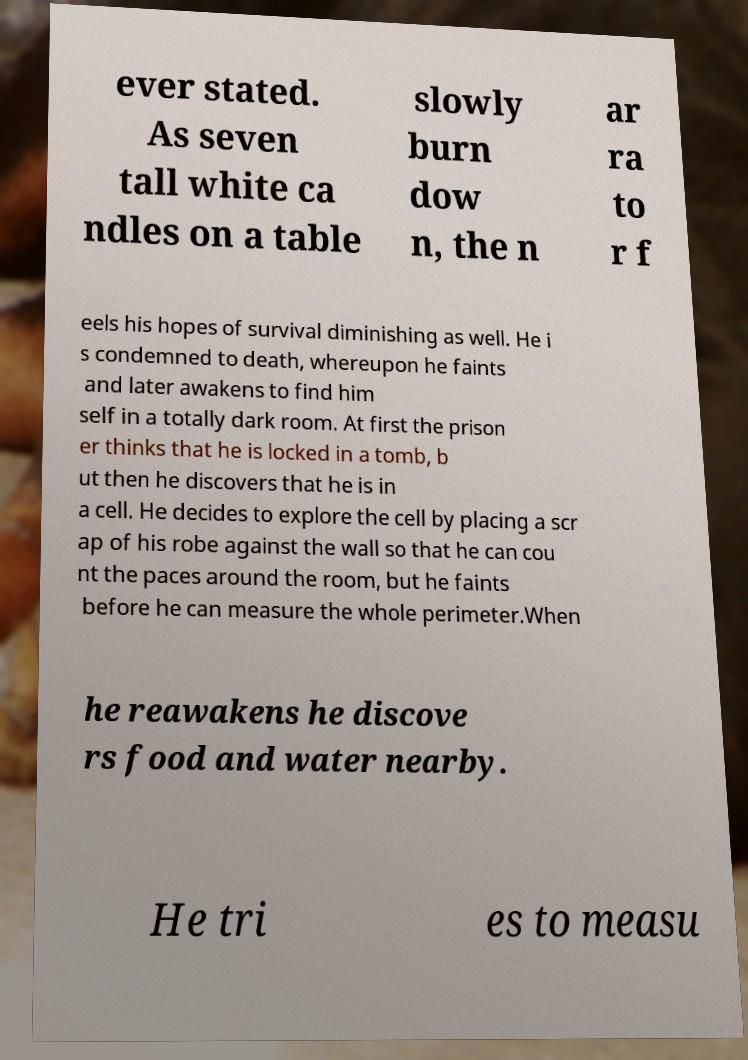Could you extract and type out the text from this image? ever stated. As seven tall white ca ndles on a table slowly burn dow n, the n ar ra to r f eels his hopes of survival diminishing as well. He i s condemned to death, whereupon he faints and later awakens to find him self in a totally dark room. At first the prison er thinks that he is locked in a tomb, b ut then he discovers that he is in a cell. He decides to explore the cell by placing a scr ap of his robe against the wall so that he can cou nt the paces around the room, but he faints before he can measure the whole perimeter.When he reawakens he discove rs food and water nearby. He tri es to measu 